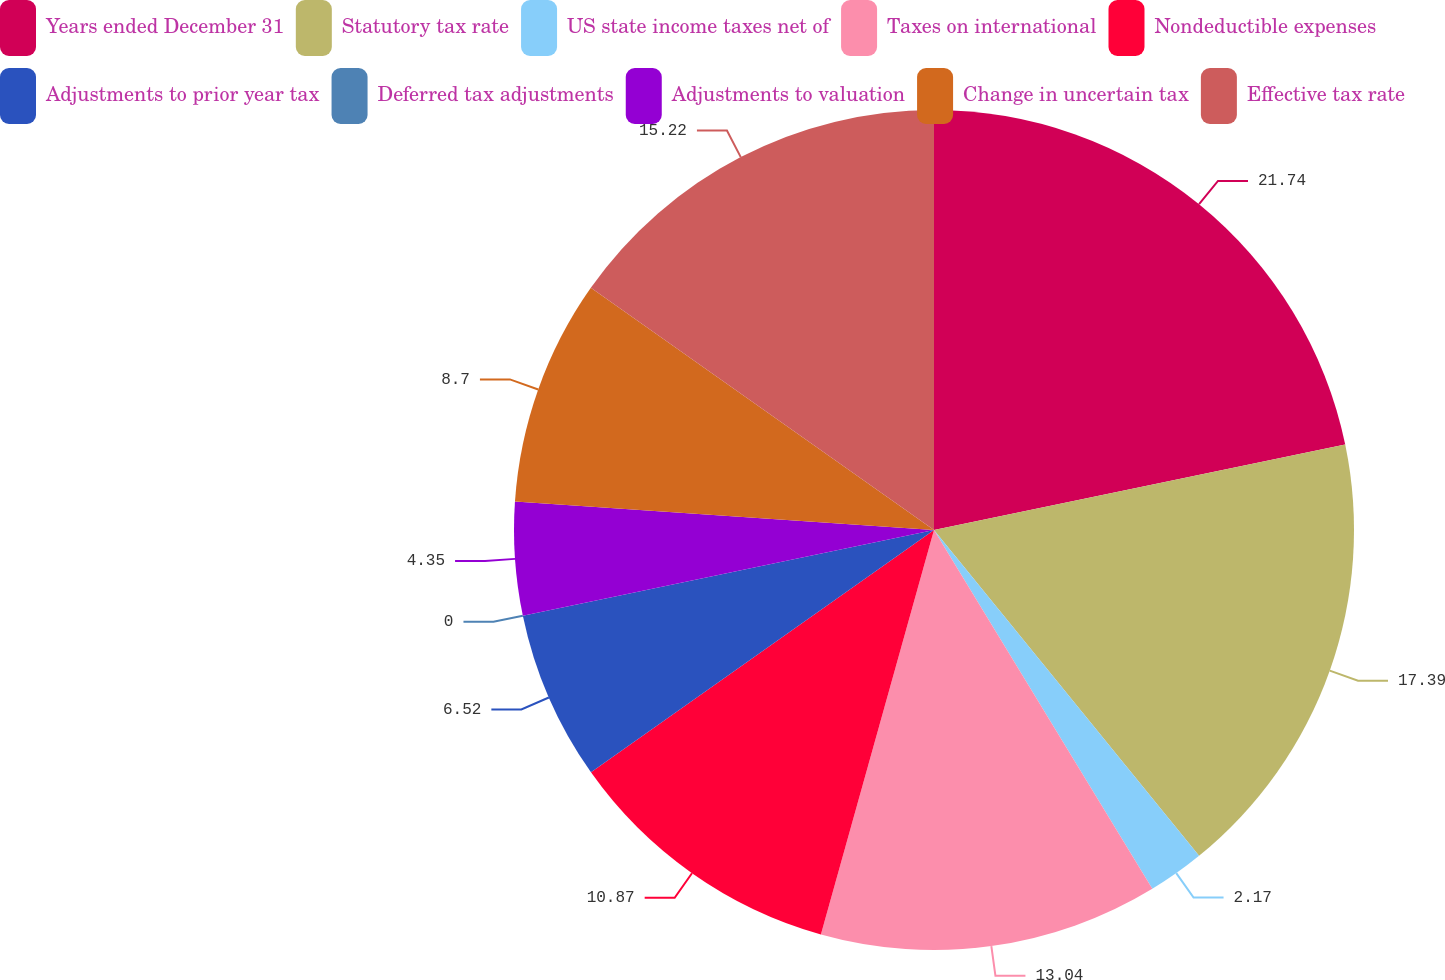<chart> <loc_0><loc_0><loc_500><loc_500><pie_chart><fcel>Years ended December 31<fcel>Statutory tax rate<fcel>US state income taxes net of<fcel>Taxes on international<fcel>Nondeductible expenses<fcel>Adjustments to prior year tax<fcel>Deferred tax adjustments<fcel>Adjustments to valuation<fcel>Change in uncertain tax<fcel>Effective tax rate<nl><fcel>21.74%<fcel>17.39%<fcel>2.17%<fcel>13.04%<fcel>10.87%<fcel>6.52%<fcel>0.0%<fcel>4.35%<fcel>8.7%<fcel>15.22%<nl></chart> 